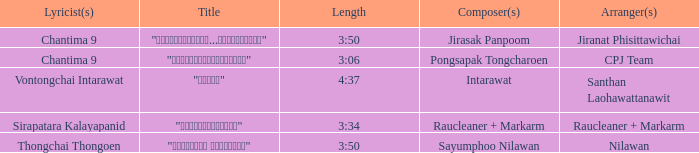Who was the arranger of "ขอโทษ"? Santhan Laohawattanawit. 